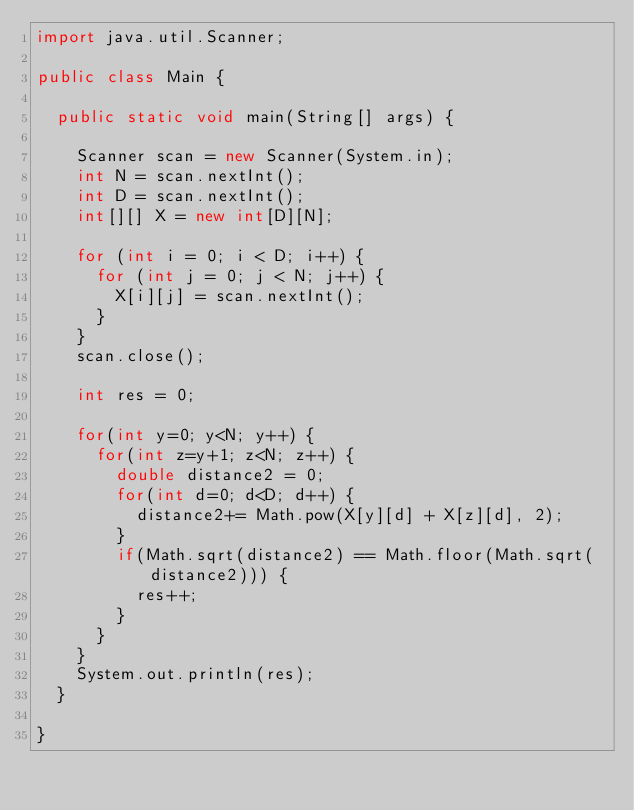<code> <loc_0><loc_0><loc_500><loc_500><_Java_>import java.util.Scanner;

public class Main {

	public static void main(String[] args) {

		Scanner scan = new Scanner(System.in);
		int N = scan.nextInt();
		int D = scan.nextInt();
		int[][] X = new int[D][N];

		for (int i = 0; i < D; i++) {
			for (int j = 0; j < N; j++) {
				X[i][j] = scan.nextInt();
			}
		}
		scan.close();

		int res = 0;

		for(int y=0; y<N; y++) {
			for(int z=y+1; z<N; z++) {
				double distance2 = 0;
				for(int d=0; d<D; d++) {
					distance2+= Math.pow(X[y][d] + X[z][d], 2);
				}
				if(Math.sqrt(distance2) == Math.floor(Math.sqrt(distance2))) {
					res++;
				}
			}
		}
		System.out.println(res);
	}

}</code> 